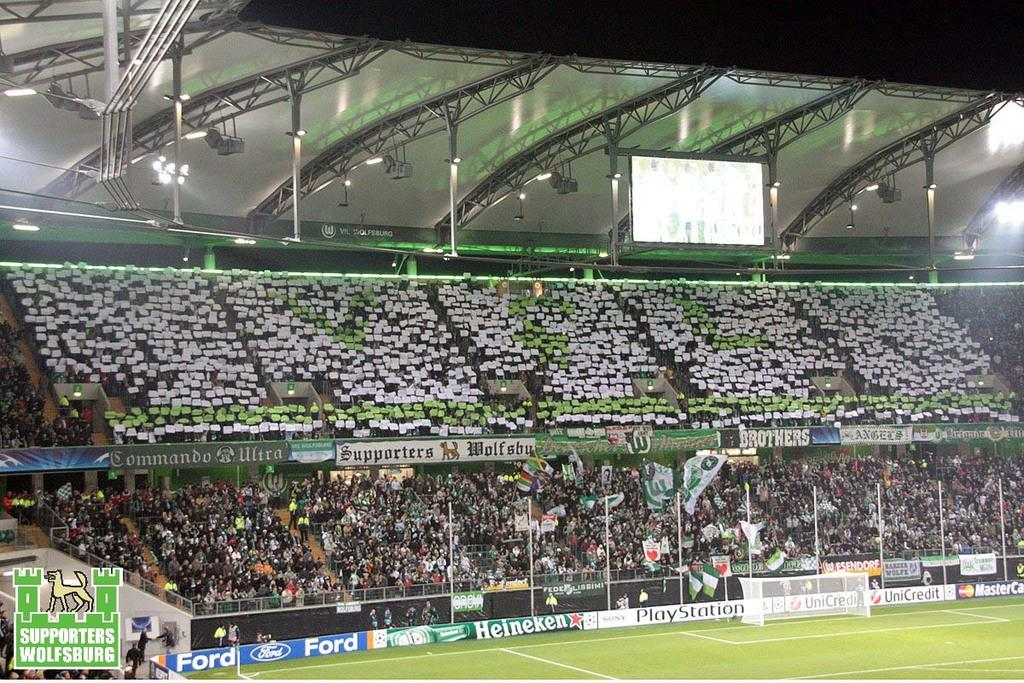How many people are in the image? There are many people in the image. What are the people doing in the image? The people are sitting on chairs. Where are the chairs located in the image? The chairs are in the center of the image. What type of location is suggested by the image? The setting appears to be a stadium. What can be seen at the top of the image? There is a roof visible at the top side of the image. What type of disease is being treated in the image? There is no indication of a disease or treatment in the image; it features people sitting on chairs in a stadium setting. How many beans are visible in the image? There are no beans present in the image. 